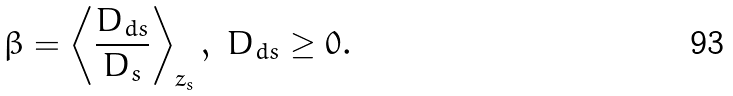<formula> <loc_0><loc_0><loc_500><loc_500>\beta = \left < \frac { D _ { d s } } { D _ { s } } \right > _ { z _ { s } } , \ D _ { d s } \geq 0 .</formula> 